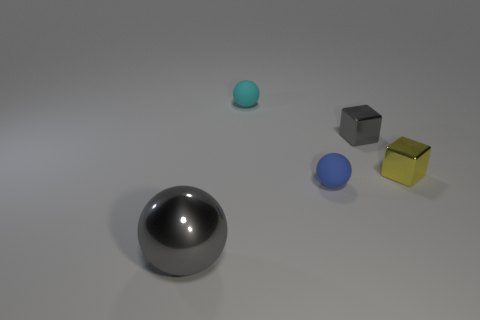Subtract all tiny matte spheres. How many spheres are left? 1 Add 1 tiny blue rubber things. How many objects exist? 6 Subtract all spheres. How many objects are left? 2 Subtract all cyan things. Subtract all large yellow matte spheres. How many objects are left? 4 Add 5 tiny spheres. How many tiny spheres are left? 7 Add 5 small matte objects. How many small matte objects exist? 7 Subtract 0 brown cylinders. How many objects are left? 5 